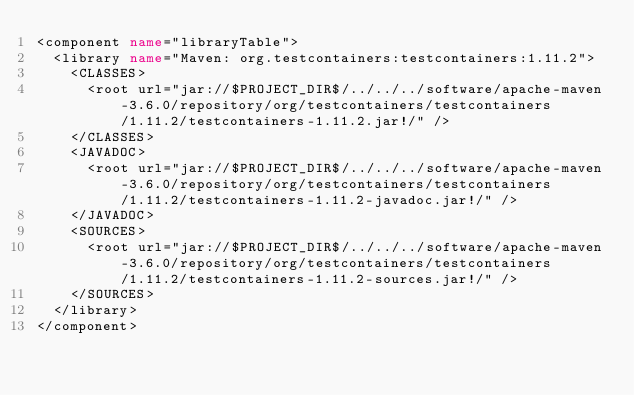Convert code to text. <code><loc_0><loc_0><loc_500><loc_500><_XML_><component name="libraryTable">
  <library name="Maven: org.testcontainers:testcontainers:1.11.2">
    <CLASSES>
      <root url="jar://$PROJECT_DIR$/../../../software/apache-maven-3.6.0/repository/org/testcontainers/testcontainers/1.11.2/testcontainers-1.11.2.jar!/" />
    </CLASSES>
    <JAVADOC>
      <root url="jar://$PROJECT_DIR$/../../../software/apache-maven-3.6.0/repository/org/testcontainers/testcontainers/1.11.2/testcontainers-1.11.2-javadoc.jar!/" />
    </JAVADOC>
    <SOURCES>
      <root url="jar://$PROJECT_DIR$/../../../software/apache-maven-3.6.0/repository/org/testcontainers/testcontainers/1.11.2/testcontainers-1.11.2-sources.jar!/" />
    </SOURCES>
  </library>
</component></code> 